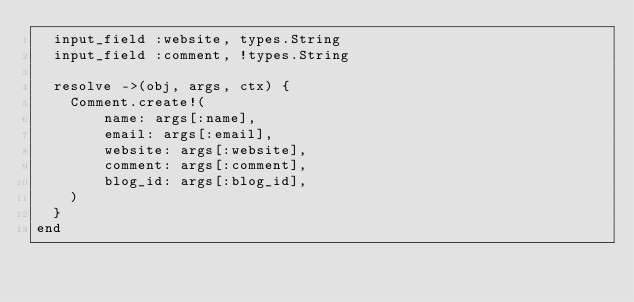Convert code to text. <code><loc_0><loc_0><loc_500><loc_500><_Ruby_>  input_field :website, types.String
  input_field :comment, !types.String

  resolve ->(obj, args, ctx) {
    Comment.create!(
        name: args[:name],
        email: args[:email],
        website: args[:website],
        comment: args[:comment],
        blog_id: args[:blog_id],
    )
  }
end
</code> 